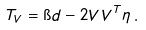Convert formula to latex. <formula><loc_0><loc_0><loc_500><loc_500>T _ { V } = \i d - 2 V V ^ { T } \eta \, .</formula> 